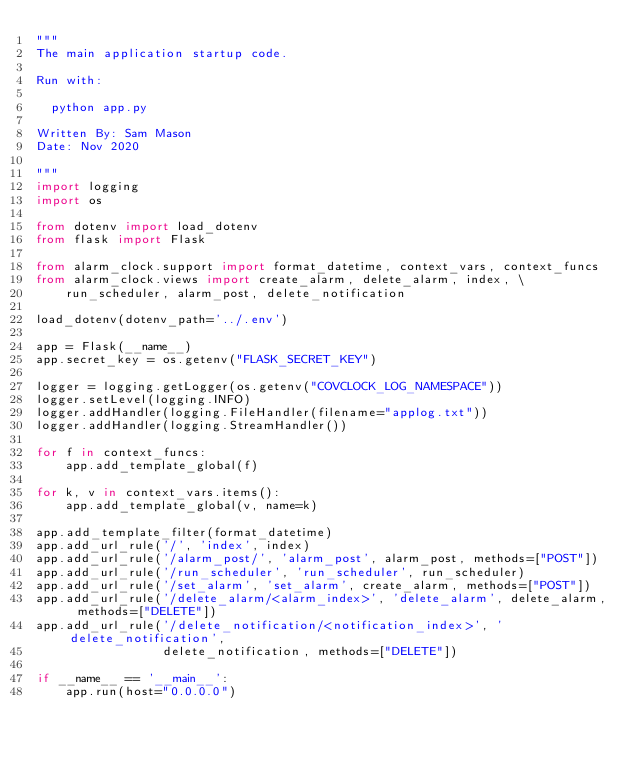Convert code to text. <code><loc_0><loc_0><loc_500><loc_500><_Python_>"""
The main application startup code.

Run with:

  python app.py

Written By: Sam Mason
Date: Nov 2020

"""
import logging
import os

from dotenv import load_dotenv
from flask import Flask

from alarm_clock.support import format_datetime, context_vars, context_funcs
from alarm_clock.views import create_alarm, delete_alarm, index, \
    run_scheduler, alarm_post, delete_notification

load_dotenv(dotenv_path='../.env')

app = Flask(__name__)
app.secret_key = os.getenv("FLASK_SECRET_KEY")

logger = logging.getLogger(os.getenv("COVCLOCK_LOG_NAMESPACE"))
logger.setLevel(logging.INFO)
logger.addHandler(logging.FileHandler(filename="applog.txt"))
logger.addHandler(logging.StreamHandler())

for f in context_funcs:
    app.add_template_global(f)

for k, v in context_vars.items():
    app.add_template_global(v, name=k)

app.add_template_filter(format_datetime)
app.add_url_rule('/', 'index', index)
app.add_url_rule('/alarm_post/', 'alarm_post', alarm_post, methods=["POST"])
app.add_url_rule('/run_scheduler', 'run_scheduler', run_scheduler)
app.add_url_rule('/set_alarm', 'set_alarm', create_alarm, methods=["POST"])
app.add_url_rule('/delete_alarm/<alarm_index>', 'delete_alarm', delete_alarm, methods=["DELETE"])
app.add_url_rule('/delete_notification/<notification_index>', 'delete_notification',
                 delete_notification, methods=["DELETE"])

if __name__ == '__main__':
    app.run(host="0.0.0.0")
</code> 